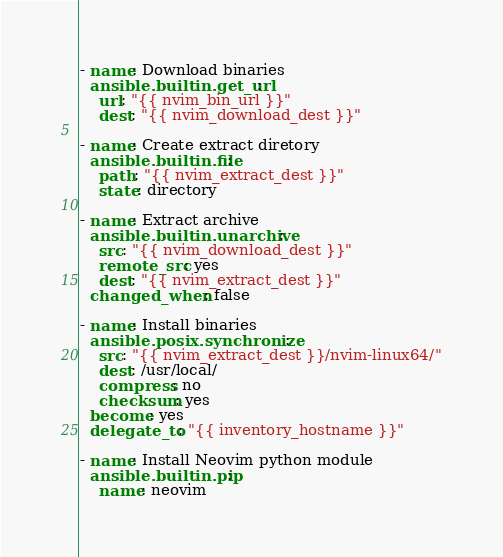<code> <loc_0><loc_0><loc_500><loc_500><_YAML_>- name: Download binaries
  ansible.builtin.get_url:
    url: "{{ nvim_bin_url }}"
    dest: "{{ nvim_download_dest }}"

- name: Create extract diretory
  ansible.builtin.file:
    path: "{{ nvim_extract_dest }}"
    state: directory

- name: Extract archive
  ansible.builtin.unarchive:
    src: "{{ nvim_download_dest }}"
    remote_src: yes
    dest: "{{ nvim_extract_dest }}"
  changed_when: false

- name: Install binaries
  ansible.posix.synchronize:
    src: "{{ nvim_extract_dest }}/nvim-linux64/"
    dest: /usr/local/
    compress: no
    checksum: yes
  become: yes
  delegate_to: "{{ inventory_hostname }}"

- name: Install Neovim python module
  ansible.builtin.pip:
    name: neovim
</code> 